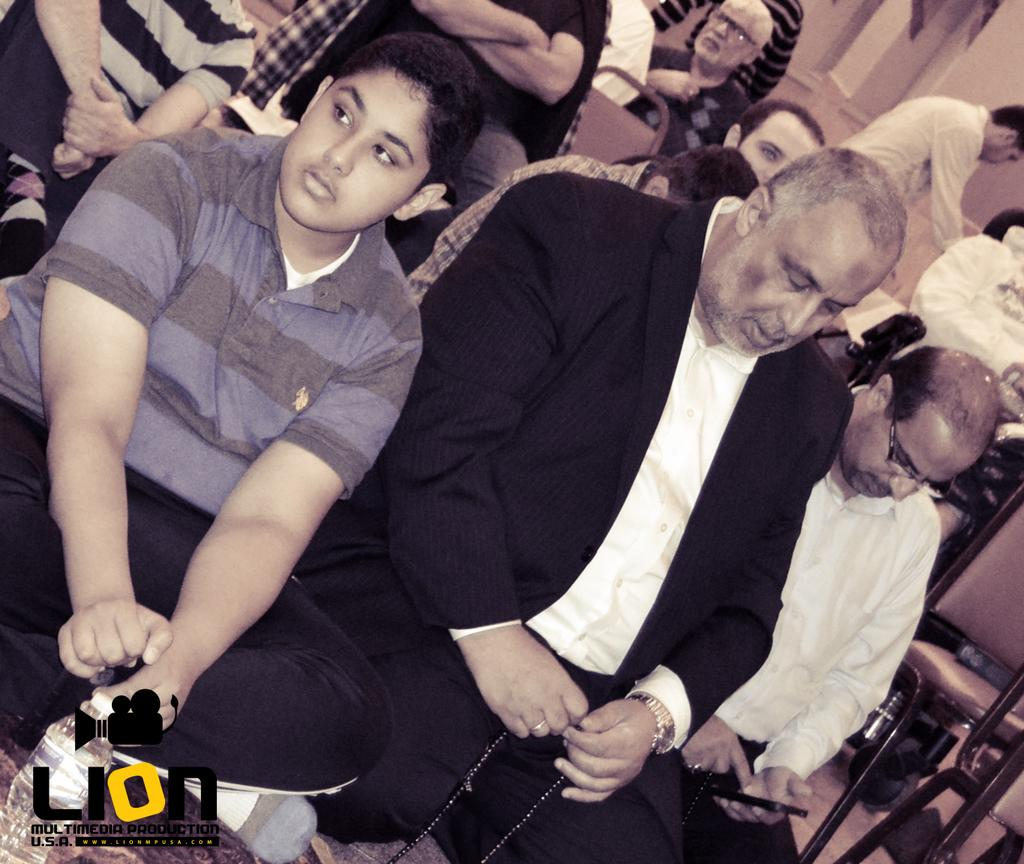What are the people in the image doing? The people in the image are sitting. Can you describe the man in the center of the image? The man in the center of the image is sitting and holding a chain. What object is at the bottom of the image? There is a bottle at the bottom of the image. What type of furniture is visible in the image? Chairs are visible in the image. What can be seen in the background of the image? There is a wall in the background of the image. How many children are talking to the man in the image? There are no children present in the image, and the man is not talking to anyone. 